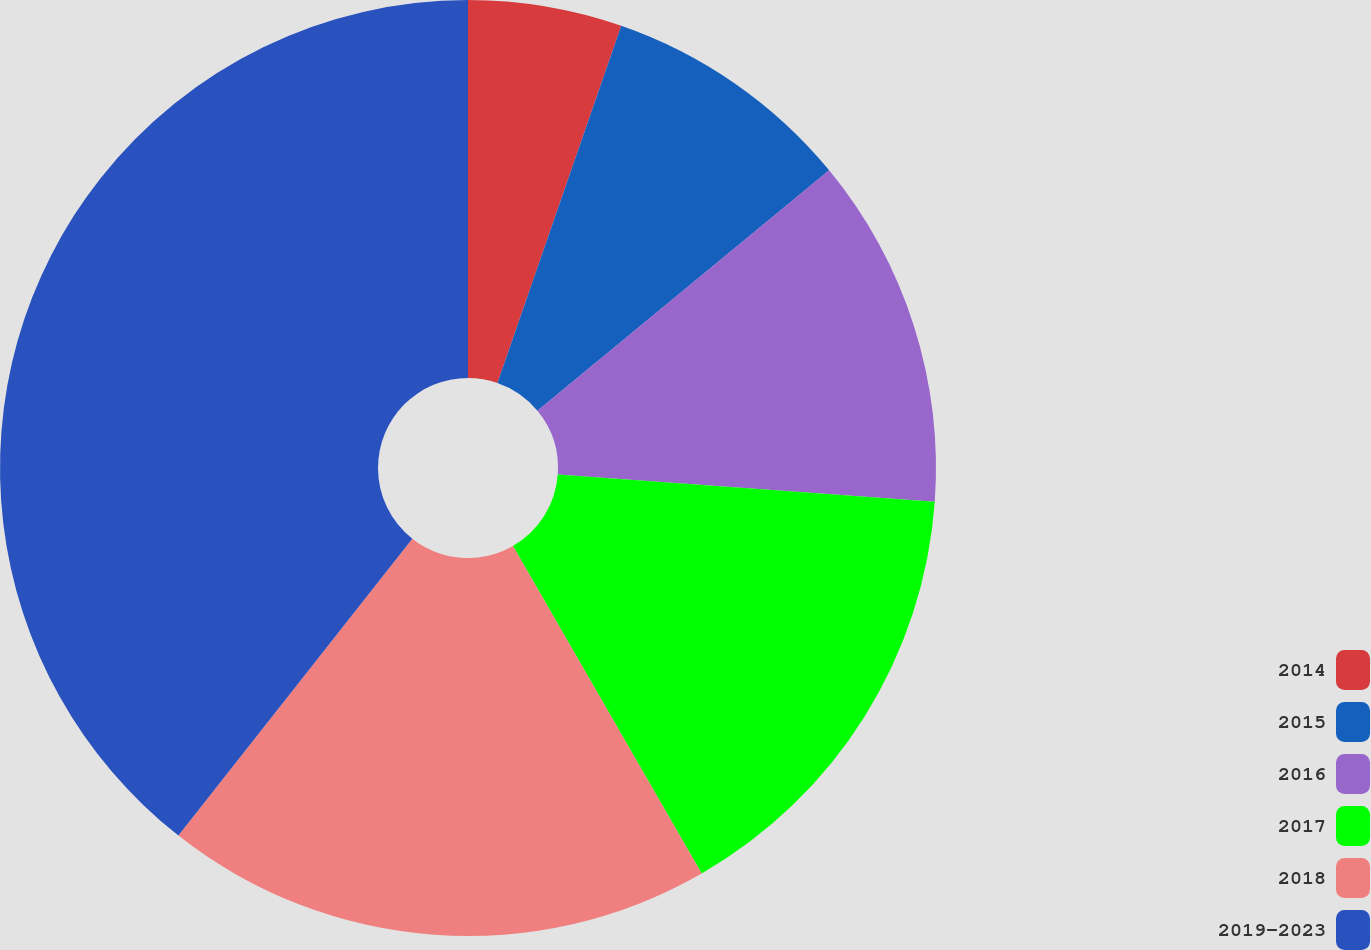Convert chart. <chart><loc_0><loc_0><loc_500><loc_500><pie_chart><fcel>2014<fcel>2015<fcel>2016<fcel>2017<fcel>2018<fcel>2019-2023<nl><fcel>5.31%<fcel>8.72%<fcel>12.12%<fcel>15.53%<fcel>18.94%<fcel>39.38%<nl></chart> 